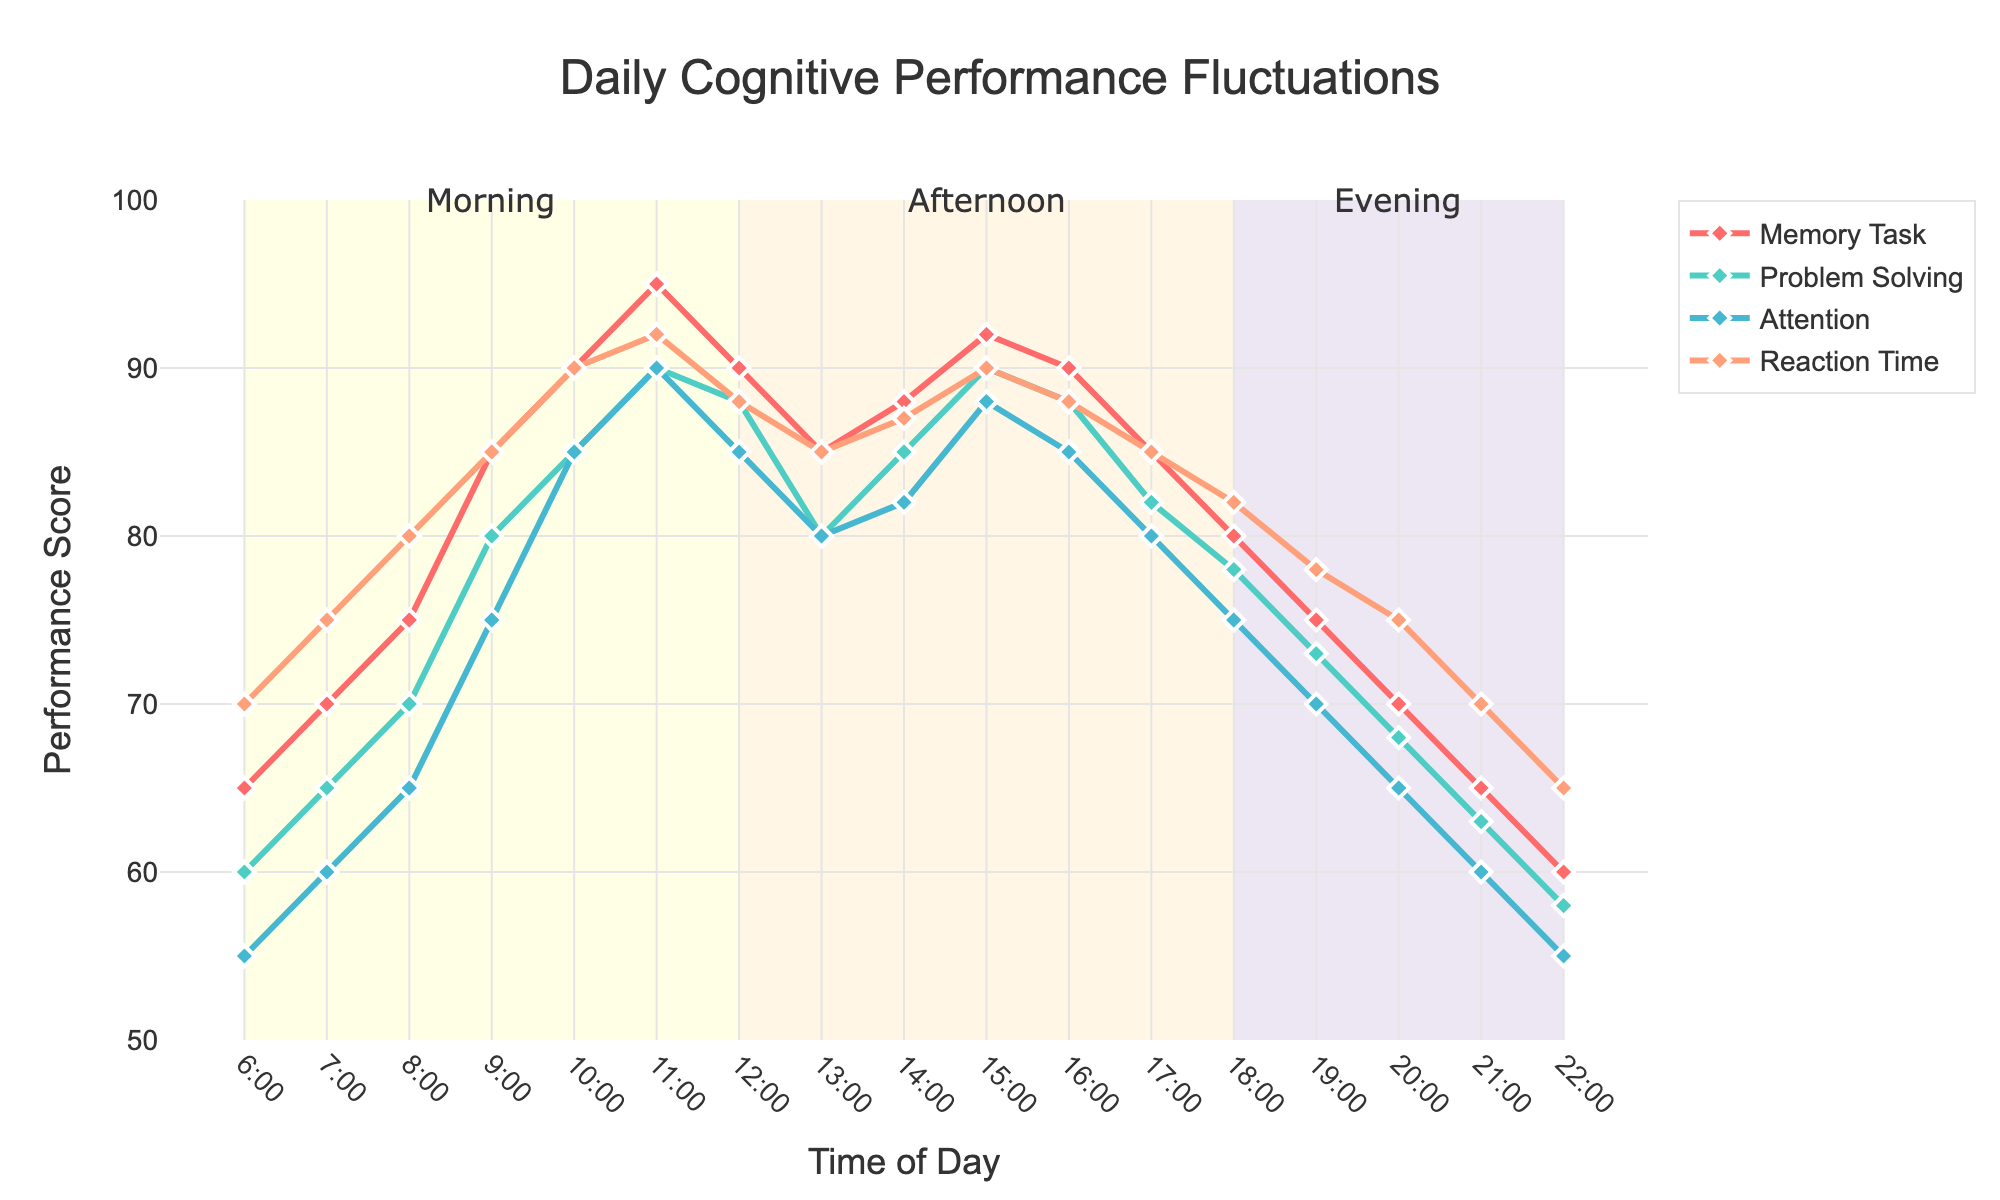What time of day did the 'Memory Task' performance peak? Look at the points for 'Memory Task' and identify the highest value. The peak performance is at 95, occurring at 11:00.
Answer: 11:00 How does the performance in 'Problem Solving' at 7:00 compare to 'Attention' at the same time? Look at the performance scores for 7:00 for both 'Problem Solving' and 'Attention'. 'Problem Solving' is 65, and 'Attention' is 60, showing that 'Problem Solving' is higher.
Answer: Higher Which task shows the most consistent performance throughout the day? Review the lines and observe how much they fluctuate. 'Reaction Time' fluctuates the least among the tasks, indicating the most consistent performance.
Answer: Reaction Time By how many points did 'Attention' decrease from 10:00 to 22:00? Find the scores for 'Attention' at 10:00 and 22:00. At 10:00 it's 85, and at 22:00 it's 55. The difference or decrease is 85 - 55 = 30.
Answer: 30 What is the average performance score for 'Reaction Time' from 6:00 to 12:00? Add the 'Reaction Time' scores from 6:00 to 12:00 (70 + 75 + 80 + 85 + 90 + 92 + 88) and divide by the number of entries, which is 7. (70 + 75 + 80 + 85 + 90 + 92 + 88) / 7 = 580 / 7 ≈ 82.9
Answer: 82.9 At what times was the performance score for 'Problem Solving' exactly 85? Examine the 'Problem Solving' line and find the time points when the score is 85. This occurs at 10:00 and 14:00.
Answer: 10:00 and 14:00 Compare the trend of 'Memory Task' and 'Problem Solving' from 6:00 to 12:00. Observe both lines for the 'Memory Task' and 'Problem Solving' from 6:00 to 12:00. Both are generally rising, but 'Memory Task' increases more steeply, reaching its peak at 11:00, then falling at 12:00.
Answer: Both rising, 'Memory Task' more steeply Was the 'Attention' performance score higher in the afternoon (12:00 to 18:00) or evening (18:00 to 22:00)? Calculate the average 'Attention' score for each period: 
Afternoon (85+80+82+88+85+80)/6=83.3
Evening (75+70+65+60)/4=67.5 
83.3 is greater than 67.5, so the performance was higher in the afternoon.
Answer: Afternoon What is the difference between the highest and lowest 'Reaction Time' scores throughout the day? Identify the maximum and minimum 'Reaction Time' scores from the data. The highest is 92 (11:00) and the lowest is 65 (22:00). The difference is 92 - 65 = 27.
Answer: 27 At what hour does the average performance score across all tasks first exceed 75? Calculate the average score for each hour and find when it first exceeds 75. 
For 9:00: (85+80+75+85)/4=81.25
It first exceeds at 9:00.
Answer: 9:00 